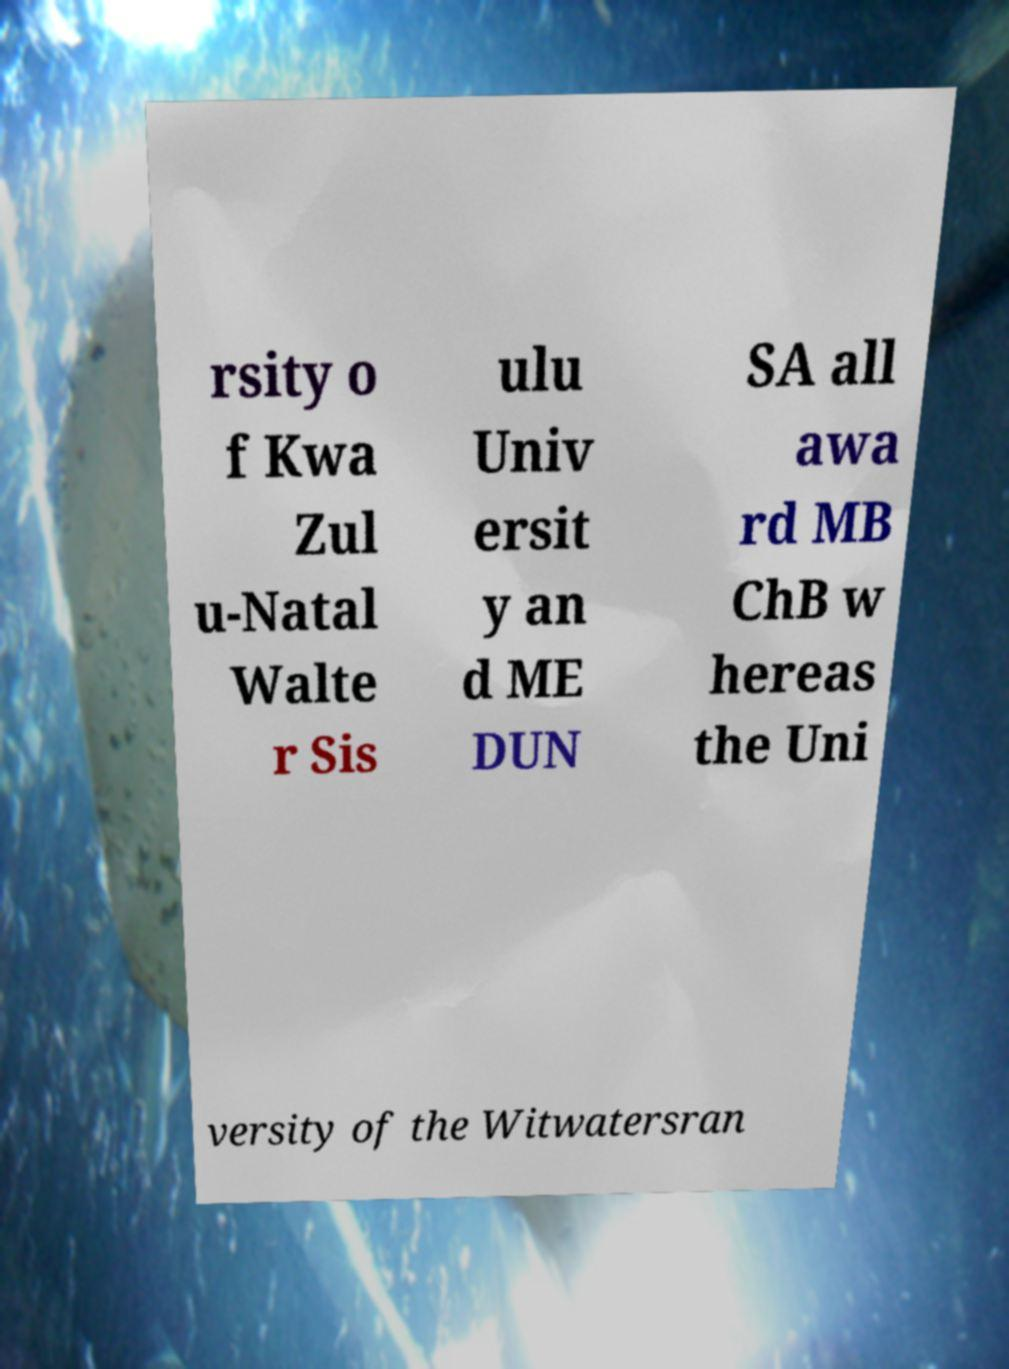I need the written content from this picture converted into text. Can you do that? rsity o f Kwa Zul u-Natal Walte r Sis ulu Univ ersit y an d ME DUN SA all awa rd MB ChB w hereas the Uni versity of the Witwatersran 